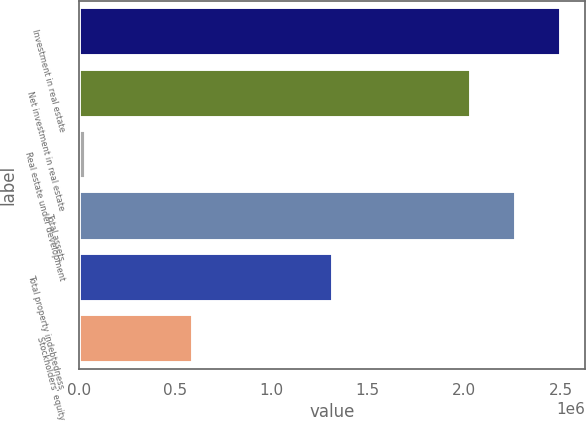Convert chart to OTSL. <chart><loc_0><loc_0><loc_500><loc_500><bar_chart><fcel>Investment in real estate<fcel>Net investment in real estate<fcel>Real estate under development<fcel>Total assets<fcel>Total property indebtedness<fcel>Stockholders' equity<nl><fcel>2.50253e+06<fcel>2.03595e+06<fcel>38320<fcel>2.26924e+06<fcel>1.31698e+06<fcel>591277<nl></chart> 